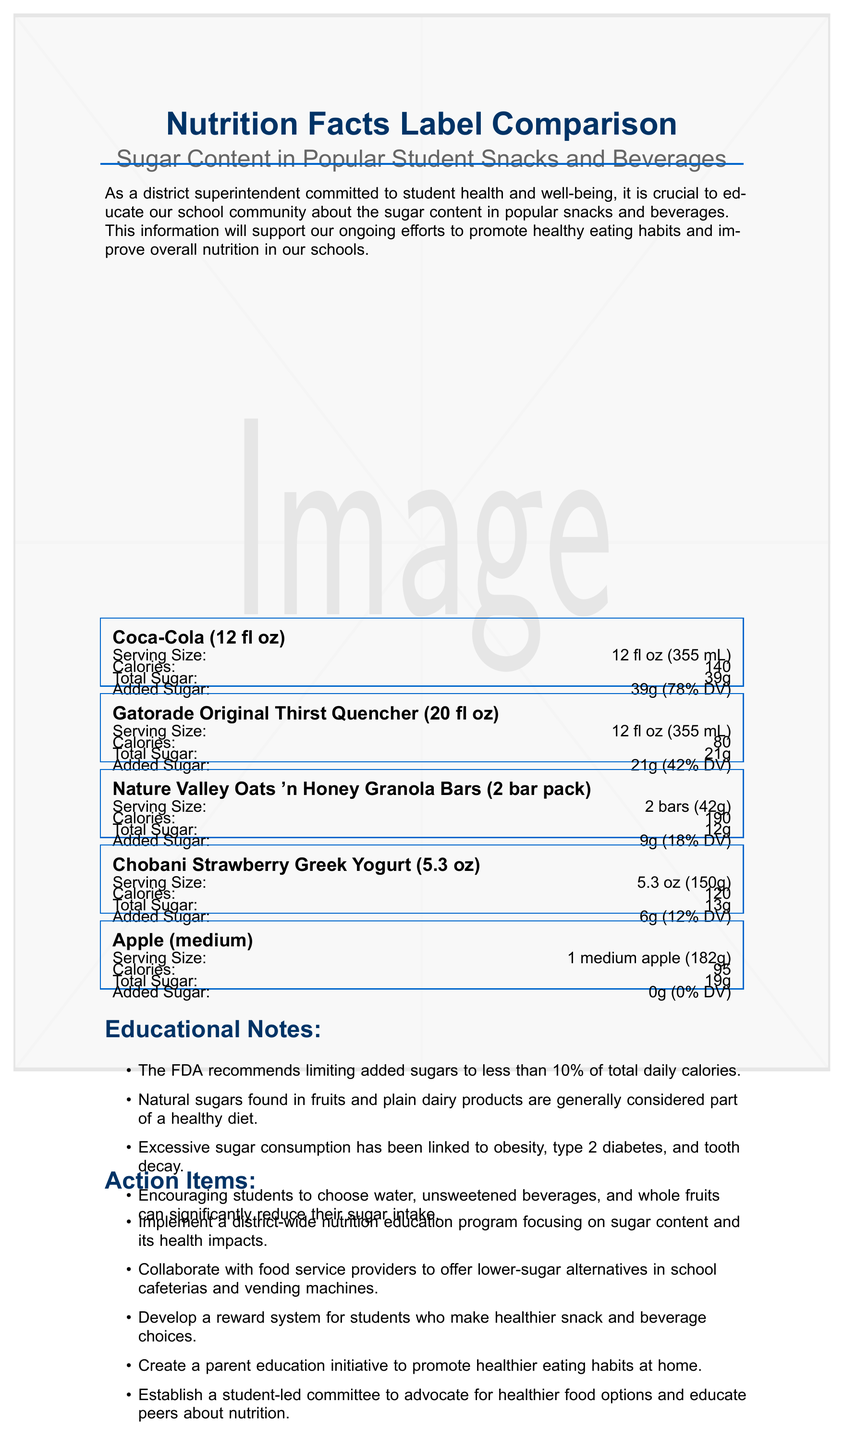what is the total sugar content in a serving of Coca-Cola (12 fl oz)? The document lists the total sugar content for a 12 fl oz serving of Coca-Cola as 39g.
Answer: 39g how much added sugar does the Nature Valley Oats 'n Honey Granola Bars contain? According to the document, the Nature Valley Oats 'n Honey Granola Bars contain 9g of added sugar per serving.
Answer: 9g what is the serving size of Gatorade Original Thirst Quencher (20 fl oz)? The serving size for Gatorade Original Thirst Quencher (20 fl oz) is specified as 12 fl oz (355 mL) in the document.
Answer: 12 fl oz (355 mL) how many calories are there in a Chobani Strawberry Greek Yogurt? The document states that a serving of Chobani Strawberry Greek Yogurt (5.3 oz) has 120 calories.
Answer: 120 what is the percent daily value of sugar in an apple (medium)? The document indicates that a medium apple has 0% daily value of sugar.
Answer: 0% which snack or beverage has the highest total sugar content per serving? 
A. Coca-Cola (12 fl oz)
B. Gatorade Original Thirst Quencher (20 fl oz)
C. Nature Valley Oats 'n Honey Granola Bars (2 bar pack)
D. Chobani Strawberry Greek Yogurt (5.3 oz) According to the document, Coca-Cola (12 fl oz) contains the highest total sugar content per serving at 39g.
Answer: A which product would be the best choice for reducing added sugar intake? 
I. Coca-Cola (12 fl oz)
II. Gatorade Original Thirst Quencher (20 fl oz)
III. Nature Valley Oats 'n Honey Granola Bars (2 bar pack)
IV. Apple (medium) The document shows that the medium apple contains 0g of added sugar, making it the best choice for reducing added sugar intake.
Answer: IV does the apple contain any added sugar? The document states that the medium apple has 0g of added sugar.
Answer: No can the sugar content of the beverages listed be relied upon to make an informed decision regarding healthier options for students? The document provides detailed information about the sugar content which helps inform decisions about healthier beverage choices for students.
Answer: Yes summarize the main idea of the document. The document includes detailed nutrition facts for various snacks and beverages, educational notes about the impact of sugar consumption and recommendations, as well as action items for implementing healthier eating practices within the school district.
Answer: The document provides a comparison of the sugar content in popular student snacks and beverages, highlighting the nutritional information, educational notes, and action items to promote healthier eating habits in schools. how have student eating habits changed over the past decade? The document does not provide any information about changes in student eating habits over the past decade.
Answer: Not enough information 